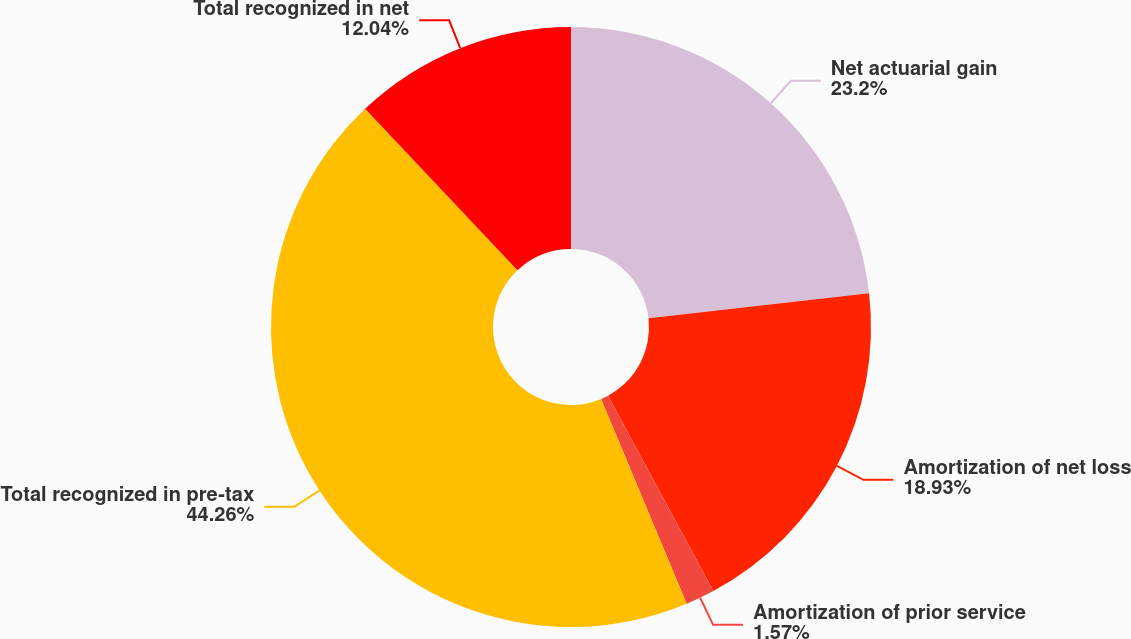Convert chart. <chart><loc_0><loc_0><loc_500><loc_500><pie_chart><fcel>Net actuarial gain<fcel>Amortization of net loss<fcel>Amortization of prior service<fcel>Total recognized in pre-tax<fcel>Total recognized in net<nl><fcel>23.2%<fcel>18.93%<fcel>1.57%<fcel>44.26%<fcel>12.04%<nl></chart> 